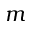<formula> <loc_0><loc_0><loc_500><loc_500>m</formula> 